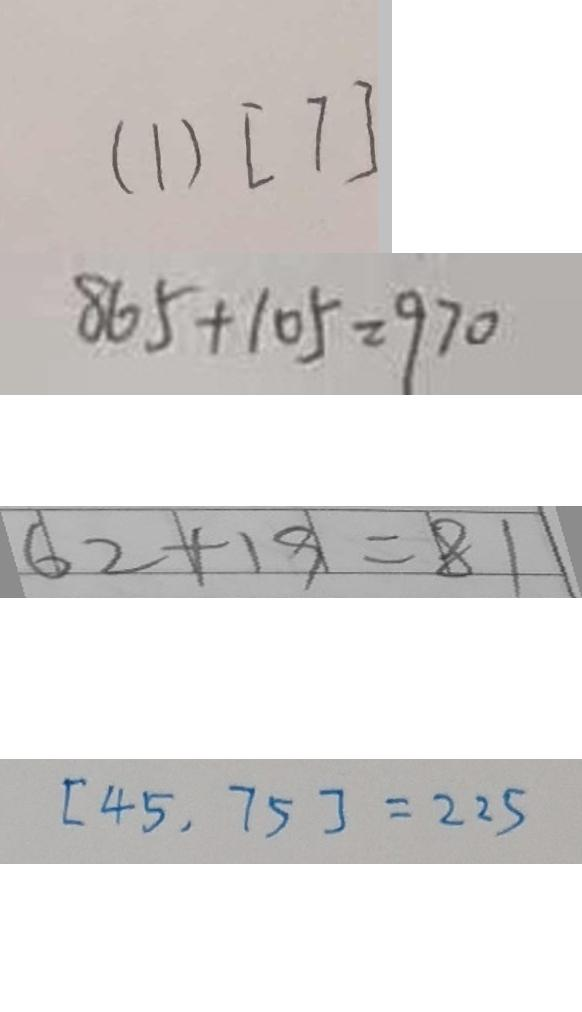<formula> <loc_0><loc_0><loc_500><loc_500>( 1 ) [ 7 ] 
 8 6 5 + 1 0 5 = 9 7 0 
 6 2 + 1 9 = 8 1 
 [ 4 5 , 7 5 ] = 2 2 5</formula> 